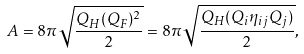<formula> <loc_0><loc_0><loc_500><loc_500>A = 8 \pi \sqrt { \frac { Q _ { H } ( Q _ { F } ) ^ { 2 } } { 2 } } = 8 \pi \sqrt { \frac { Q _ { H } ( Q _ { i } \eta _ { i j } Q _ { j } ) } { 2 } } ,</formula> 